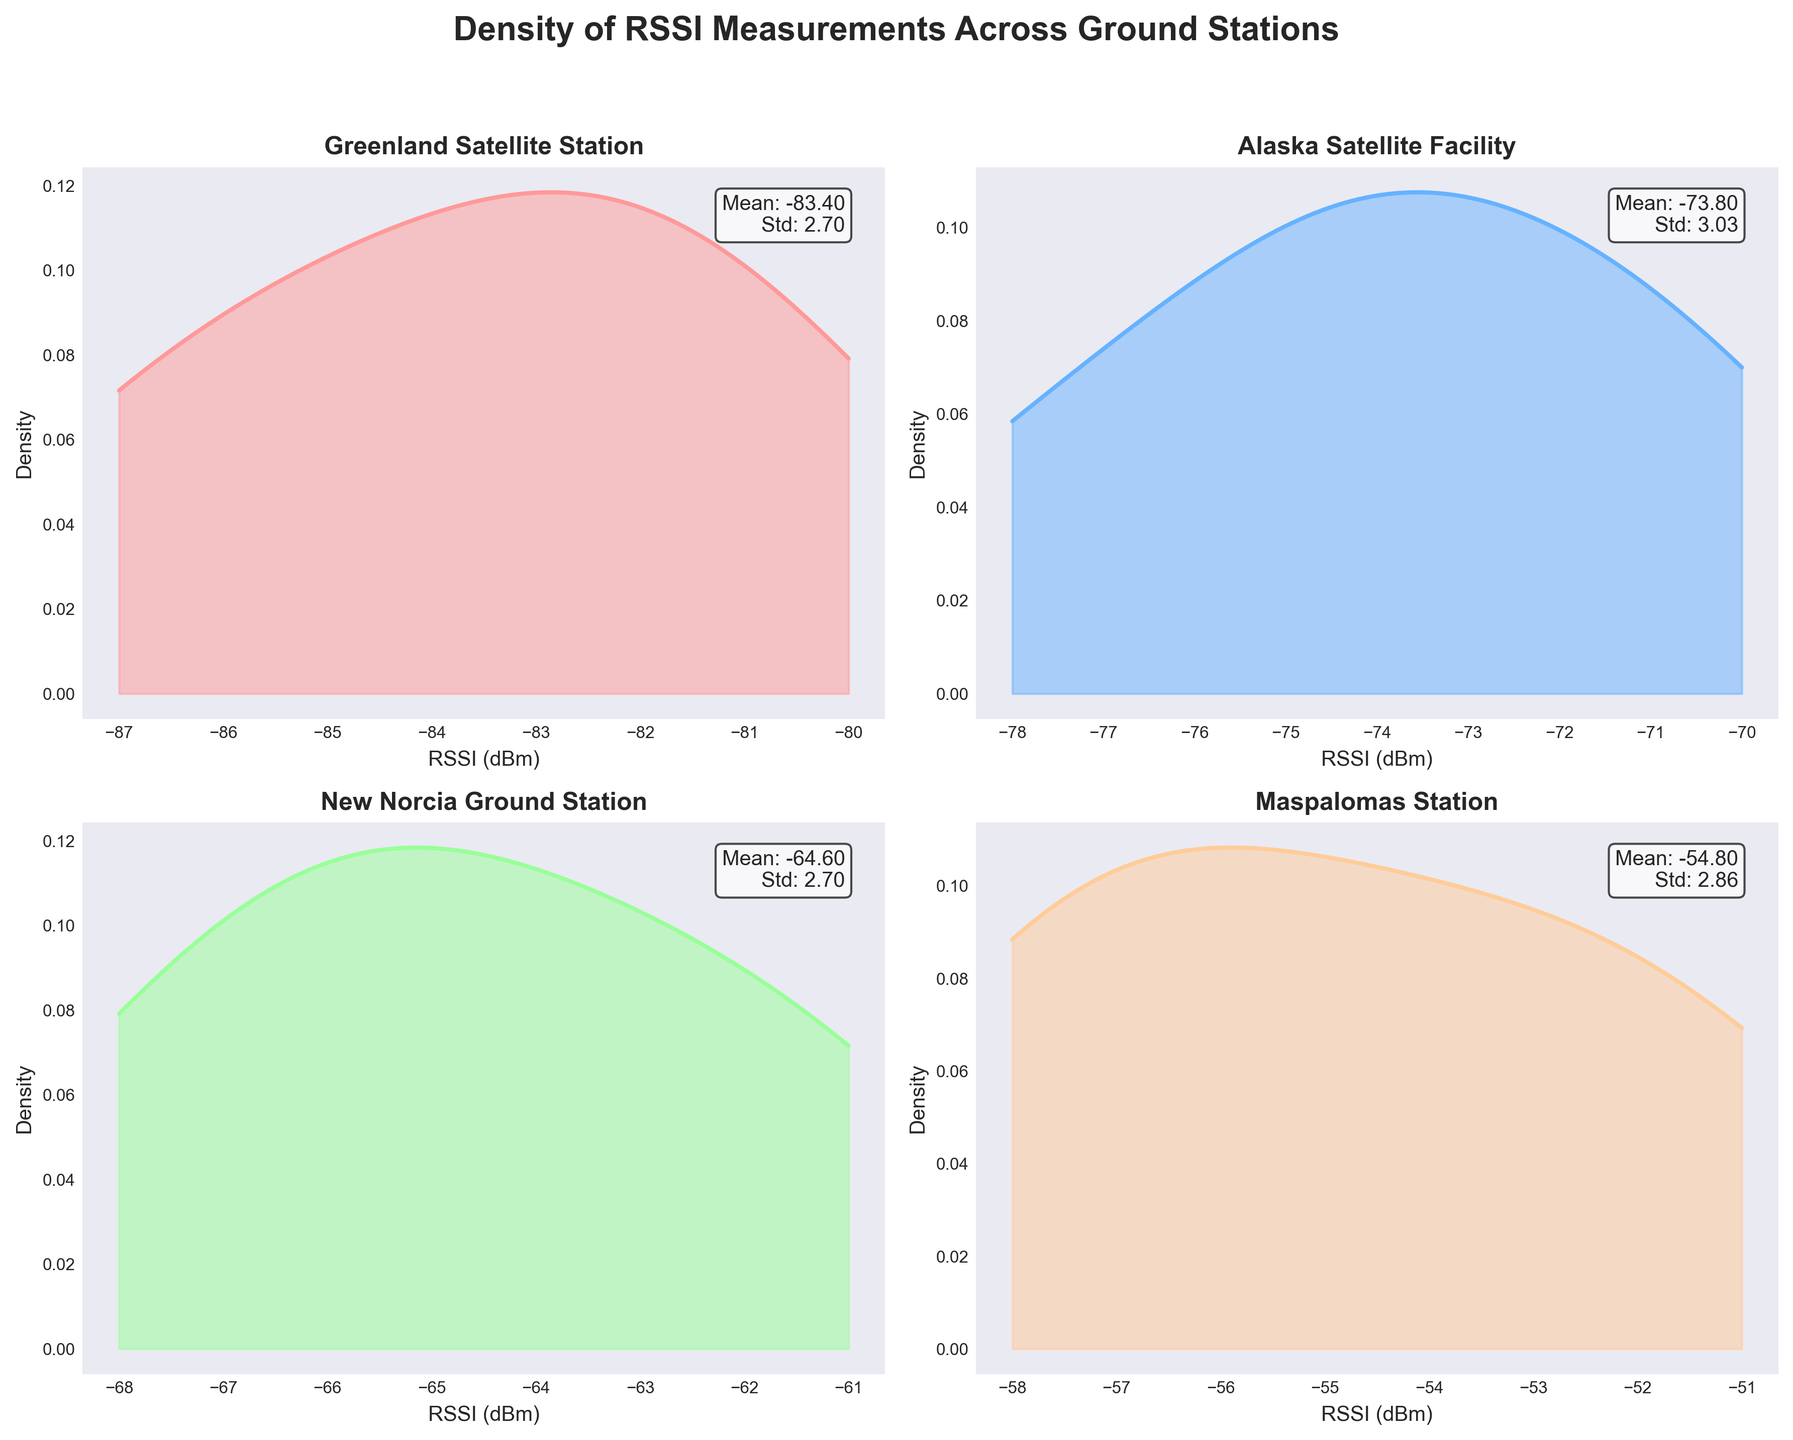What's the title of the figure? The title is located at the top center of the figure, displaying the overall theme or subject of the visualization. It reads, "Density of RSSI Measurements Across Ground Stations," which succinctly indicates the focus of the figure.
Answer: Density of RSSI Measurements Across Ground Stations Which station has the lowest average RSSI value? Each subplot shows the mean RSSI value in a text box at the upper right corner. By comparing the mean values, the Greenland Satellite Station has the lowest average RSSI value with an average approximately -83.40.
Answer: Greenland Satellite Station Which ground station shows the highest peak in the density plot? The highest peak in the density plot corresponds to the most frequent RSSI measurements for that station. The Maspalomas Station shows the highest density peak, indicating a high concentration around its central values.
Answer: Maspalomas Station What is the approximate range of RSSI values for the Alaska Satellite Facility station? By examining the plot for the Alaska Satellite Facility, the density distribution spans from approximately -78 dBm to -70 dBm, which can be inferred from the x-axis limits and the spread of the density curve within these limits.
Answer: -78 to -70 dBm How does the spread of RSSI values differ between the Greenland Satellite Station and New Norcia Ground Station? The spread can be assessed by looking at the width of the density curves. Greenland Satellite Station has a wider spread, with values ranging more broadly compared to the New Norcia Ground Station which is more concentrated and narrower.
Answer: Greenland has a wider spread; New Norcia is more concentrated What's the RSSI standard deviation for the New Norcia Ground Station? The standard deviation is shown in the annotation box at the top right corner of each subplot. For New Norcia, it is specified to be approximately 2.08 dBm.
Answer: 2.08 dBm Compare the mean RSSI values of the Maspalomas Station and Alaska Satellite Facility. Which one is higher? Each subplot indicates the mean RSSI value. By comparing the annotations, Maspalomas Station has a mean around -54.80 dBm, while Alaska Satellite Facility's mean is around -73.80 dBm. Maspalomas has the higher mean.
Answer: Maspalomas Station Which ground station has the narrowest density plot and what does it imply? The narrowness of the density plot indicates less variability in RSSI measurements. The New Norcia Ground Station has the narrowest plot, implying that its RSSI values are more consistent and closely clustered around the mean.
Answer: New Norcia Ground Station 